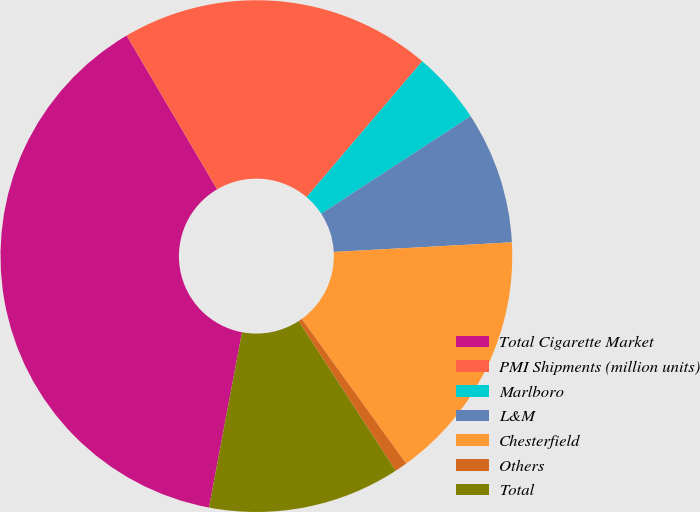Convert chart. <chart><loc_0><loc_0><loc_500><loc_500><pie_chart><fcel>Total Cigarette Market<fcel>PMI Shipments (million units)<fcel>Marlboro<fcel>L&M<fcel>Chesterfield<fcel>Others<fcel>Total<nl><fcel>38.58%<fcel>19.69%<fcel>4.57%<fcel>8.35%<fcel>15.91%<fcel>0.79%<fcel>12.13%<nl></chart> 